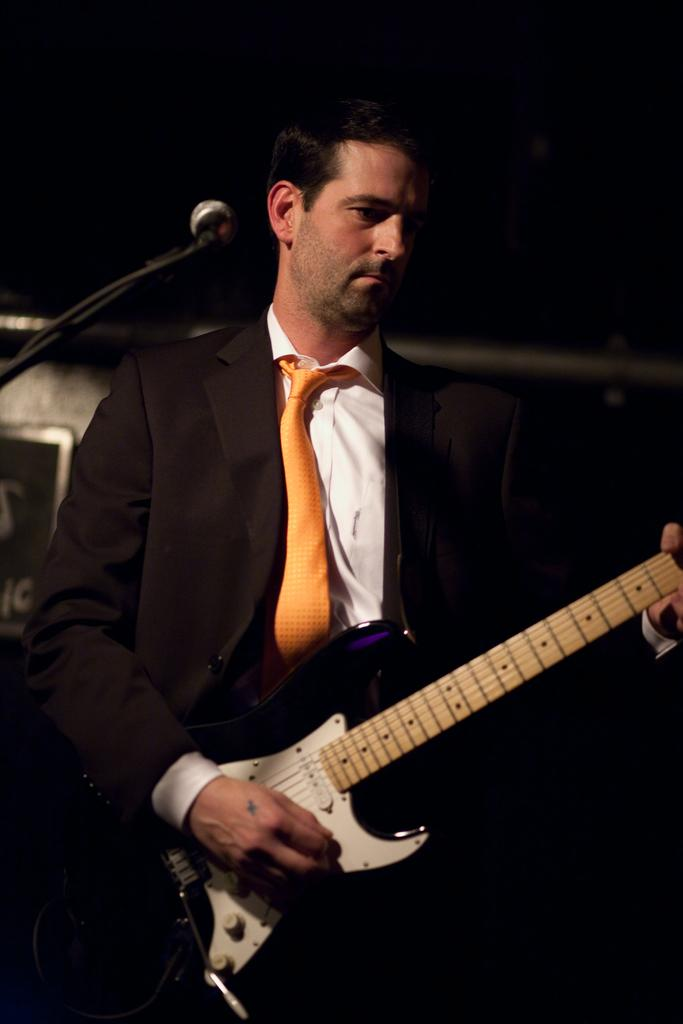What is the man wearing in the image? The man is wearing a suit and a tie. What is the man doing in the image? The man is playing a guitar. What object is the man standing in front of? The man is in front of a microphone. What is the color of the background in the image? The background is black. What type of teeth does the man's aunt have in the image? There is no mention of teeth, the man's aunt, or any other person in the image. The image only features a man playing a guitar in front of a microphone. 